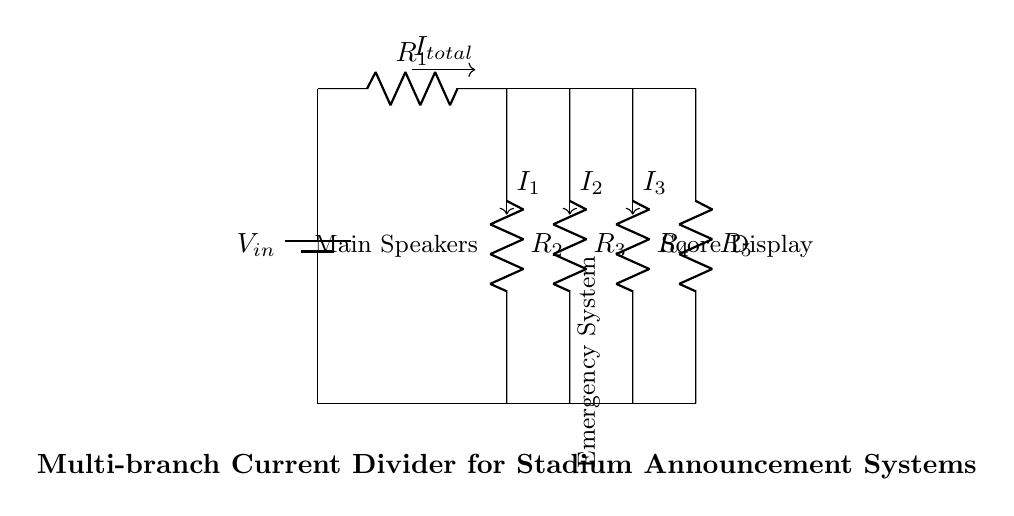What is the input voltage for this circuit? The input voltage is labeled as V_{in} on the battery symbol at the top left of the circuit diagram. Although the value is not specified, it is the voltage supplied to the entire circuit.
Answer: V_{in} What component represents the emergency system? The emergency system is represented by the resistor labeled R_{3}, which is connected to a branch coming off the main current path. It's indicated with a label near it in the diagram.
Answer: R_{3} How many branches does the current divider have? The current divider consists of three distinct branches, which are designated for the main speakers, emergency system, and score display. These branches connect to the main current path.
Answer: Three What is the total current entering the circuit marked as? The total current entering the circuit is labeled I_{total}, shown with an arrow above the input point of the circuit and indicating the flow into the branches.
Answer: I_{total} Which branch has the lowest resistance? In order to determine which branch has the lowest resistance, you would generally compare the labeled resistors R_{2}, R_{3}, and R_{4}. Without specific values, we can only refer to their labels, but you can deduce it based on their placement in the diagram. The actual values would determine the answer.
Answer: Cannot determine What is the function of resistor R_{1}? Resistor R_{1} is the only resistor in the main current path before the branches, so it functions to limit the current entering the divider and sets the overall characteristics of the circuit.
Answer: Limit current What current flows to the main speakers? The current flowing to the main speakers is labeled I_{1}, which is an output current from the first branch and can be read directly from the circuit.
Answer: I_{1} 